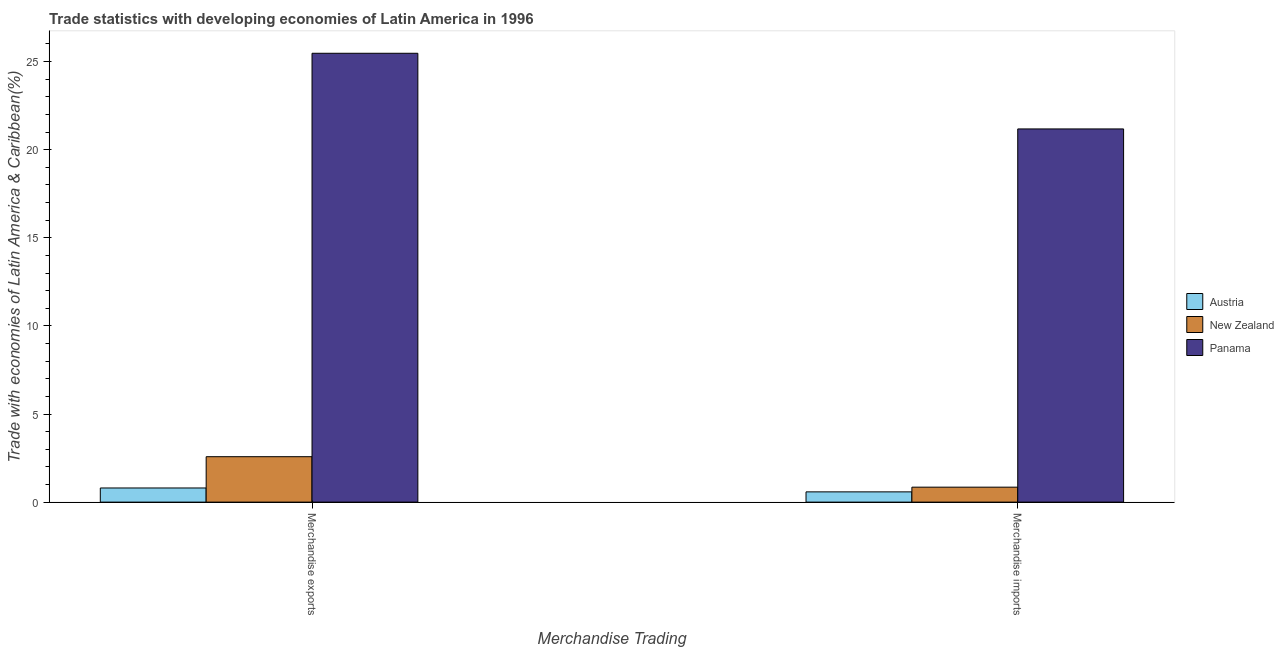How many groups of bars are there?
Keep it short and to the point. 2. Are the number of bars on each tick of the X-axis equal?
Ensure brevity in your answer.  Yes. How many bars are there on the 1st tick from the right?
Your answer should be very brief. 3. What is the merchandise imports in New Zealand?
Offer a very short reply. 0.85. Across all countries, what is the maximum merchandise imports?
Offer a very short reply. 21.18. Across all countries, what is the minimum merchandise imports?
Your answer should be very brief. 0.58. In which country was the merchandise exports maximum?
Provide a short and direct response. Panama. What is the total merchandise exports in the graph?
Keep it short and to the point. 28.85. What is the difference between the merchandise imports in Panama and that in New Zealand?
Your response must be concise. 20.33. What is the difference between the merchandise exports in New Zealand and the merchandise imports in Panama?
Your answer should be very brief. -18.6. What is the average merchandise imports per country?
Provide a succinct answer. 7.54. What is the difference between the merchandise exports and merchandise imports in New Zealand?
Keep it short and to the point. 1.73. What is the ratio of the merchandise exports in Austria to that in Panama?
Your answer should be very brief. 0.03. What does the 1st bar from the left in Merchandise exports represents?
Your answer should be compact. Austria. What does the 1st bar from the right in Merchandise exports represents?
Your response must be concise. Panama. How many countries are there in the graph?
Provide a succinct answer. 3. What is the difference between two consecutive major ticks on the Y-axis?
Offer a terse response. 5. Are the values on the major ticks of Y-axis written in scientific E-notation?
Your answer should be very brief. No. Does the graph contain any zero values?
Offer a very short reply. No. Does the graph contain grids?
Ensure brevity in your answer.  No. How many legend labels are there?
Your answer should be compact. 3. How are the legend labels stacked?
Provide a succinct answer. Vertical. What is the title of the graph?
Provide a succinct answer. Trade statistics with developing economies of Latin America in 1996. Does "Belarus" appear as one of the legend labels in the graph?
Provide a short and direct response. No. What is the label or title of the X-axis?
Provide a short and direct response. Merchandise Trading. What is the label or title of the Y-axis?
Provide a short and direct response. Trade with economies of Latin America & Caribbean(%). What is the Trade with economies of Latin America & Caribbean(%) of Austria in Merchandise exports?
Provide a short and direct response. 0.8. What is the Trade with economies of Latin America & Caribbean(%) of New Zealand in Merchandise exports?
Your answer should be very brief. 2.58. What is the Trade with economies of Latin America & Caribbean(%) in Panama in Merchandise exports?
Keep it short and to the point. 25.47. What is the Trade with economies of Latin America & Caribbean(%) in Austria in Merchandise imports?
Ensure brevity in your answer.  0.58. What is the Trade with economies of Latin America & Caribbean(%) in New Zealand in Merchandise imports?
Offer a terse response. 0.85. What is the Trade with economies of Latin America & Caribbean(%) of Panama in Merchandise imports?
Your answer should be very brief. 21.18. Across all Merchandise Trading, what is the maximum Trade with economies of Latin America & Caribbean(%) of Austria?
Offer a terse response. 0.8. Across all Merchandise Trading, what is the maximum Trade with economies of Latin America & Caribbean(%) of New Zealand?
Offer a terse response. 2.58. Across all Merchandise Trading, what is the maximum Trade with economies of Latin America & Caribbean(%) of Panama?
Offer a terse response. 25.47. Across all Merchandise Trading, what is the minimum Trade with economies of Latin America & Caribbean(%) in Austria?
Provide a short and direct response. 0.58. Across all Merchandise Trading, what is the minimum Trade with economies of Latin America & Caribbean(%) in New Zealand?
Give a very brief answer. 0.85. Across all Merchandise Trading, what is the minimum Trade with economies of Latin America & Caribbean(%) in Panama?
Ensure brevity in your answer.  21.18. What is the total Trade with economies of Latin America & Caribbean(%) in Austria in the graph?
Provide a short and direct response. 1.38. What is the total Trade with economies of Latin America & Caribbean(%) in New Zealand in the graph?
Give a very brief answer. 3.43. What is the total Trade with economies of Latin America & Caribbean(%) in Panama in the graph?
Offer a very short reply. 46.65. What is the difference between the Trade with economies of Latin America & Caribbean(%) of Austria in Merchandise exports and that in Merchandise imports?
Offer a very short reply. 0.22. What is the difference between the Trade with economies of Latin America & Caribbean(%) in New Zealand in Merchandise exports and that in Merchandise imports?
Make the answer very short. 1.73. What is the difference between the Trade with economies of Latin America & Caribbean(%) of Panama in Merchandise exports and that in Merchandise imports?
Your response must be concise. 4.29. What is the difference between the Trade with economies of Latin America & Caribbean(%) in Austria in Merchandise exports and the Trade with economies of Latin America & Caribbean(%) in New Zealand in Merchandise imports?
Offer a very short reply. -0.05. What is the difference between the Trade with economies of Latin America & Caribbean(%) in Austria in Merchandise exports and the Trade with economies of Latin America & Caribbean(%) in Panama in Merchandise imports?
Make the answer very short. -20.37. What is the difference between the Trade with economies of Latin America & Caribbean(%) of New Zealand in Merchandise exports and the Trade with economies of Latin America & Caribbean(%) of Panama in Merchandise imports?
Your answer should be compact. -18.6. What is the average Trade with economies of Latin America & Caribbean(%) of Austria per Merchandise Trading?
Ensure brevity in your answer.  0.69. What is the average Trade with economies of Latin America & Caribbean(%) of New Zealand per Merchandise Trading?
Your response must be concise. 1.71. What is the average Trade with economies of Latin America & Caribbean(%) in Panama per Merchandise Trading?
Provide a short and direct response. 23.32. What is the difference between the Trade with economies of Latin America & Caribbean(%) of Austria and Trade with economies of Latin America & Caribbean(%) of New Zealand in Merchandise exports?
Offer a very short reply. -1.78. What is the difference between the Trade with economies of Latin America & Caribbean(%) of Austria and Trade with economies of Latin America & Caribbean(%) of Panama in Merchandise exports?
Keep it short and to the point. -24.67. What is the difference between the Trade with economies of Latin America & Caribbean(%) in New Zealand and Trade with economies of Latin America & Caribbean(%) in Panama in Merchandise exports?
Make the answer very short. -22.89. What is the difference between the Trade with economies of Latin America & Caribbean(%) of Austria and Trade with economies of Latin America & Caribbean(%) of New Zealand in Merchandise imports?
Provide a succinct answer. -0.27. What is the difference between the Trade with economies of Latin America & Caribbean(%) in Austria and Trade with economies of Latin America & Caribbean(%) in Panama in Merchandise imports?
Keep it short and to the point. -20.59. What is the difference between the Trade with economies of Latin America & Caribbean(%) of New Zealand and Trade with economies of Latin America & Caribbean(%) of Panama in Merchandise imports?
Make the answer very short. -20.33. What is the ratio of the Trade with economies of Latin America & Caribbean(%) in Austria in Merchandise exports to that in Merchandise imports?
Offer a terse response. 1.38. What is the ratio of the Trade with economies of Latin America & Caribbean(%) of New Zealand in Merchandise exports to that in Merchandise imports?
Your response must be concise. 3.04. What is the ratio of the Trade with economies of Latin America & Caribbean(%) in Panama in Merchandise exports to that in Merchandise imports?
Keep it short and to the point. 1.2. What is the difference between the highest and the second highest Trade with economies of Latin America & Caribbean(%) of Austria?
Your answer should be compact. 0.22. What is the difference between the highest and the second highest Trade with economies of Latin America & Caribbean(%) of New Zealand?
Offer a very short reply. 1.73. What is the difference between the highest and the second highest Trade with economies of Latin America & Caribbean(%) of Panama?
Keep it short and to the point. 4.29. What is the difference between the highest and the lowest Trade with economies of Latin America & Caribbean(%) of Austria?
Your answer should be very brief. 0.22. What is the difference between the highest and the lowest Trade with economies of Latin America & Caribbean(%) of New Zealand?
Your response must be concise. 1.73. What is the difference between the highest and the lowest Trade with economies of Latin America & Caribbean(%) of Panama?
Your answer should be compact. 4.29. 